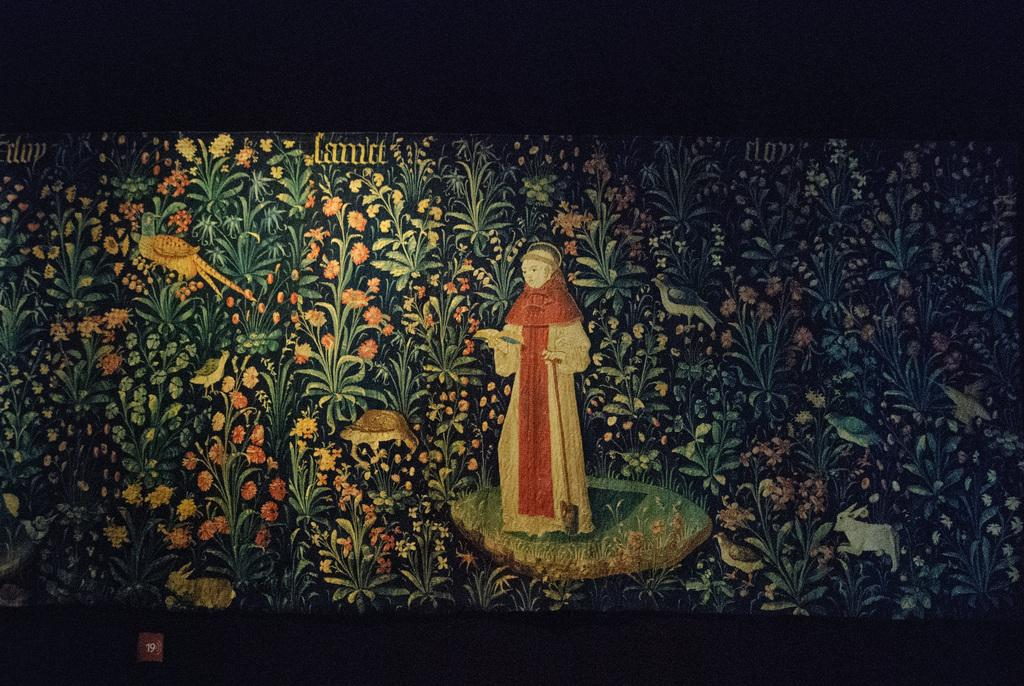What is the main subject of the image? There is a painting in the image. What is depicted in the painting? The painting depicts a person, plants, birds, and animals. Are there any words written on the image? Yes, there is text written on the image. How would you describe the lighting in the image? The image is slightly dark. What is the name of the judge depicted in the painting? There is no judge depicted in the painting; it features a person, plants, birds, and animals. How many stems are visible in the painting? The provided facts do not specify the number of stems in the painting, only that plants are included. 